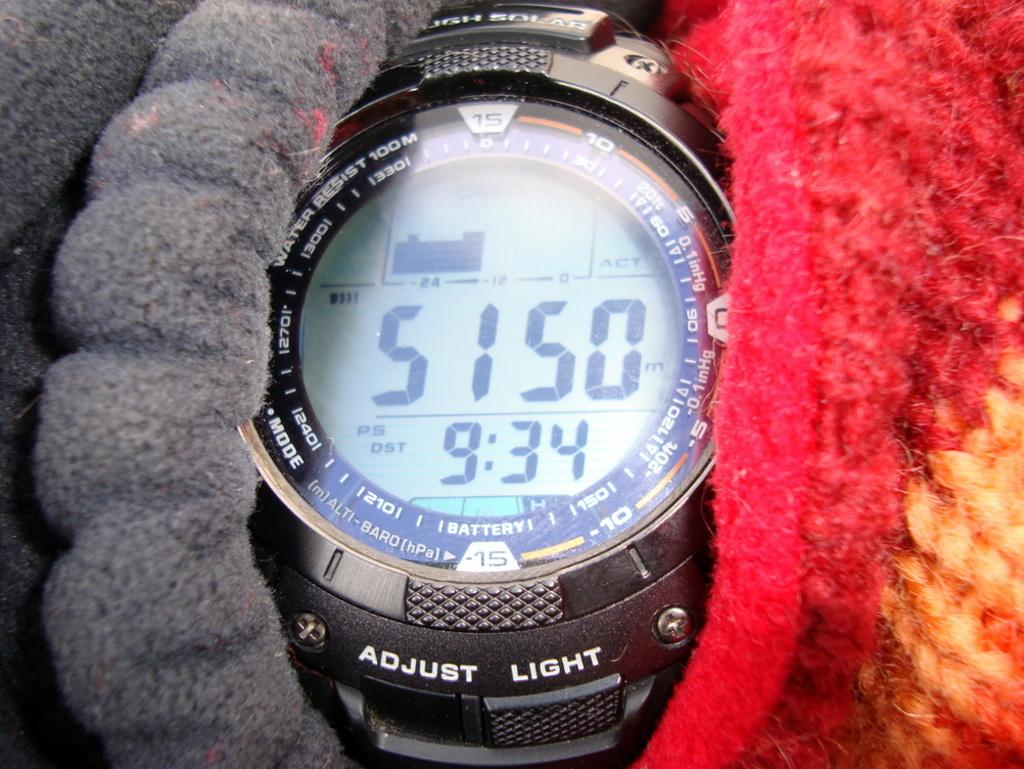<image>
Provide a brief description of the given image. Face of a watch which says "Adjust Light" near the bottom. 